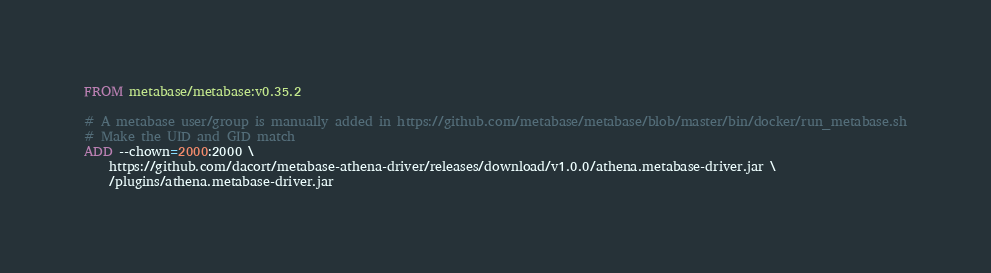<code> <loc_0><loc_0><loc_500><loc_500><_Dockerfile_>FROM metabase/metabase:v0.35.2

# A metabase user/group is manually added in https://github.com/metabase/metabase/blob/master/bin/docker/run_metabase.sh
# Make the UID and GID match
ADD --chown=2000:2000 \
    https://github.com/dacort/metabase-athena-driver/releases/download/v1.0.0/athena.metabase-driver.jar \
    /plugins/athena.metabase-driver.jar</code> 